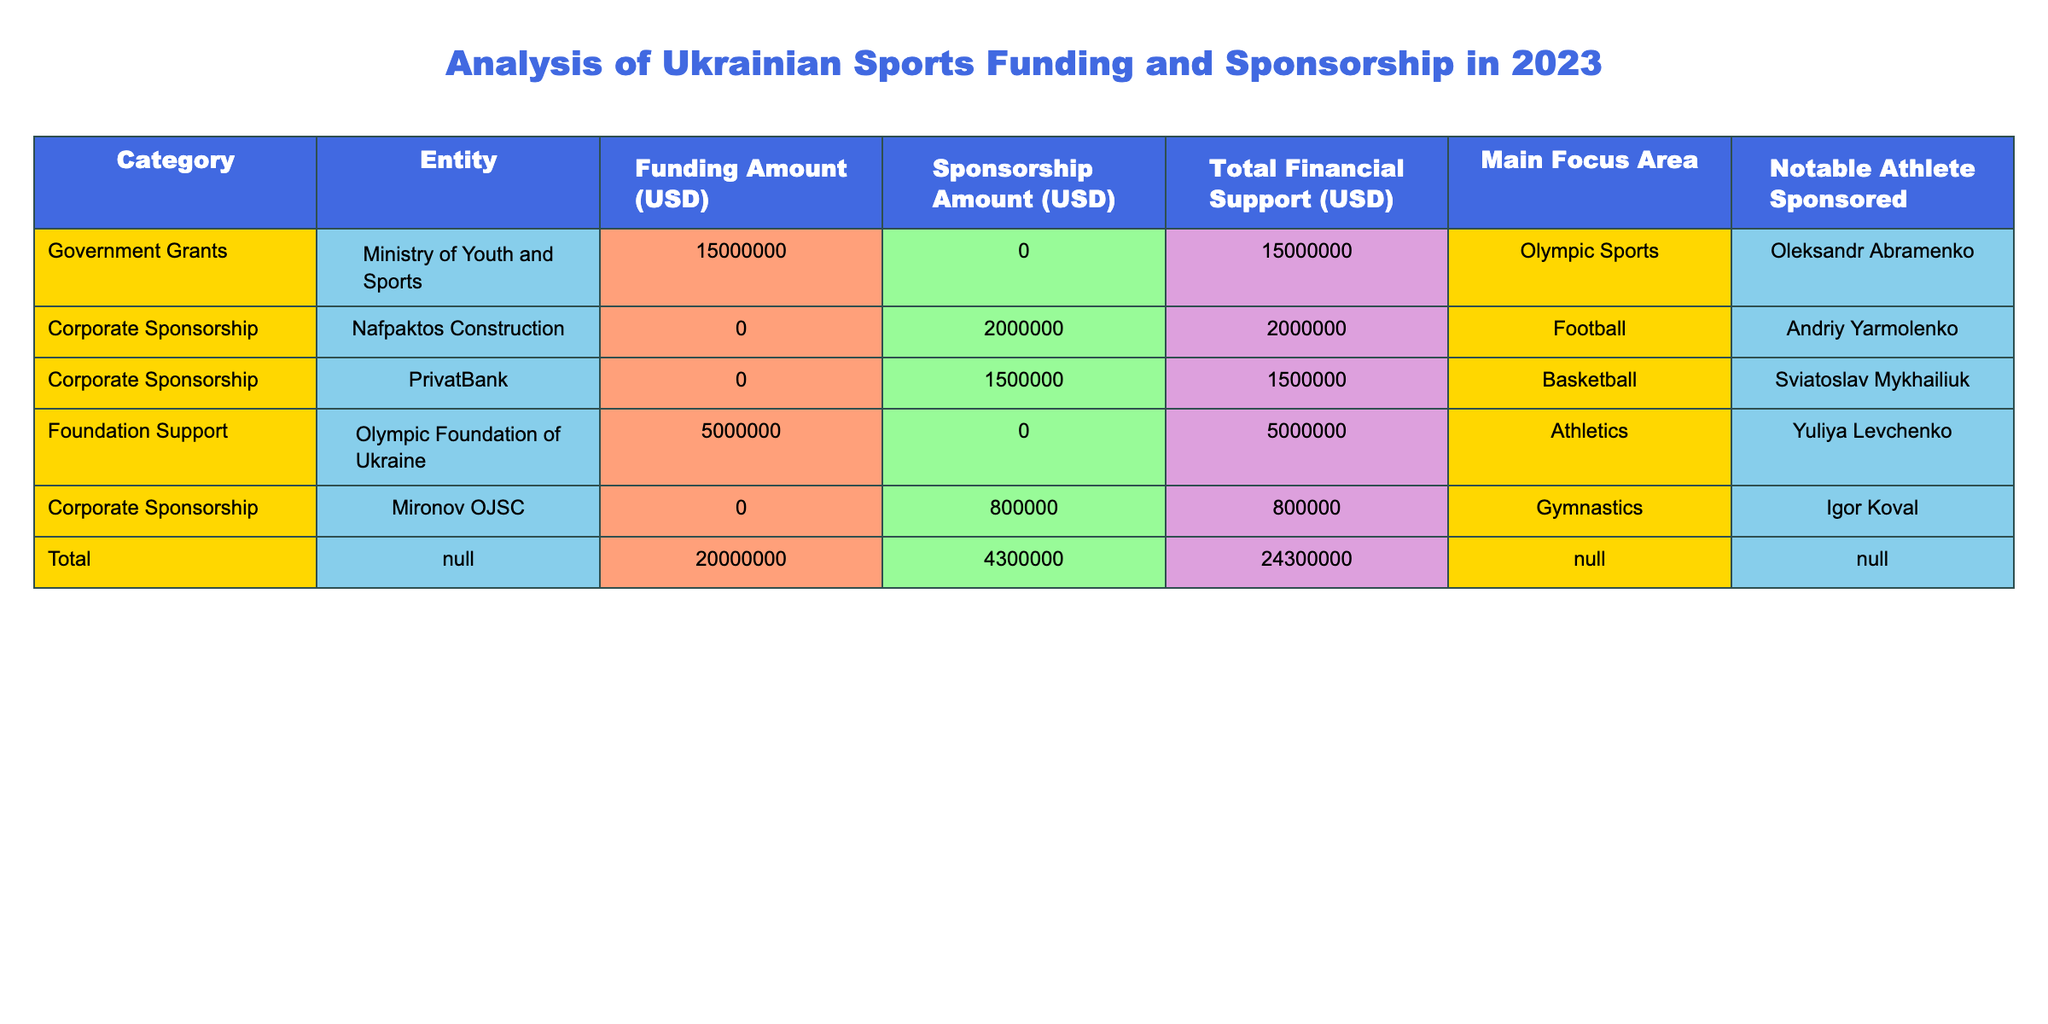What is the total funding amount provided by the Ministry of Youth and Sports? The table indicates that the Ministry of Youth and Sports provided a funding amount of 15000000 USD.
Answer: 15000000 USD Which corporate sponsorship entity sponsored a basketball athlete? According to the table, PrivatBank sponsored the basketball athlete Sviatoslav Mykhailiuk with a sponsorship amount of 1500000 USD.
Answer: PrivatBank What is the total financial support for Olympic Sports? The total financial support for Olympic Sports can be found by noting that the Ministry of Youth and Sports provided 15000000 USD, which is the only listed contribution in that area.
Answer: 15000000 USD Is there any entity that provided both funding and sponsorship? Upon reviewing the table, the Ministry of Youth and Sports is the only entity that provided funding, but it did not provide any sponsorship. Therefore, no entity provided both.
Answer: No What is the average sponsorship amount across the corporate sponsorship entities? The sponsorship amounts for corporate sponsors are: 2000000 (Nafpaktos Construction), 1500000 (PrivatBank), and 800000 (Mironov OJSC). Adding these gives a total of 2000000 + 1500000 + 800000 = 4300000 USD. The count of corporate sponsorship entities is 3, thus the average is 4300000 / 3 = 1433333.33 USD.
Answer: 1433333.33 USD What is the total financial support for athletics compared to football? The Olympic Foundation of Ukraine supported athletics with 5000000 USD and no funding was listed for football except for corporate sponsorship which contributed 2000000 USD. Thus, the total financial support for athletics is 5000000 USD, while for football it is 2000000 USD. The total for athletics (5000000) is greater than that for football (2000000).
Answer: Total support for athletics is greater Who is the notable athlete associated with the funding from the Olympic Foundation of Ukraine? The table indicates that Yuliya Levchenko is the notable athlete associated with the funding from the Olympic Foundation of Ukraine, which provided 5000000 USD.
Answer: Yuliya Levchenko What is the difference in the total financial support between government grants and corporate sponsorship? The total financial support from government grants is 15000000 USD, and from corporate sponsorship is 2000000 + 1500000 + 800000 = 4300000 USD. Therefore, the difference is 15000000 - 4300000 = 10700000 USD, showing that government grants provide significantly more support.
Answer: 10700000 USD 